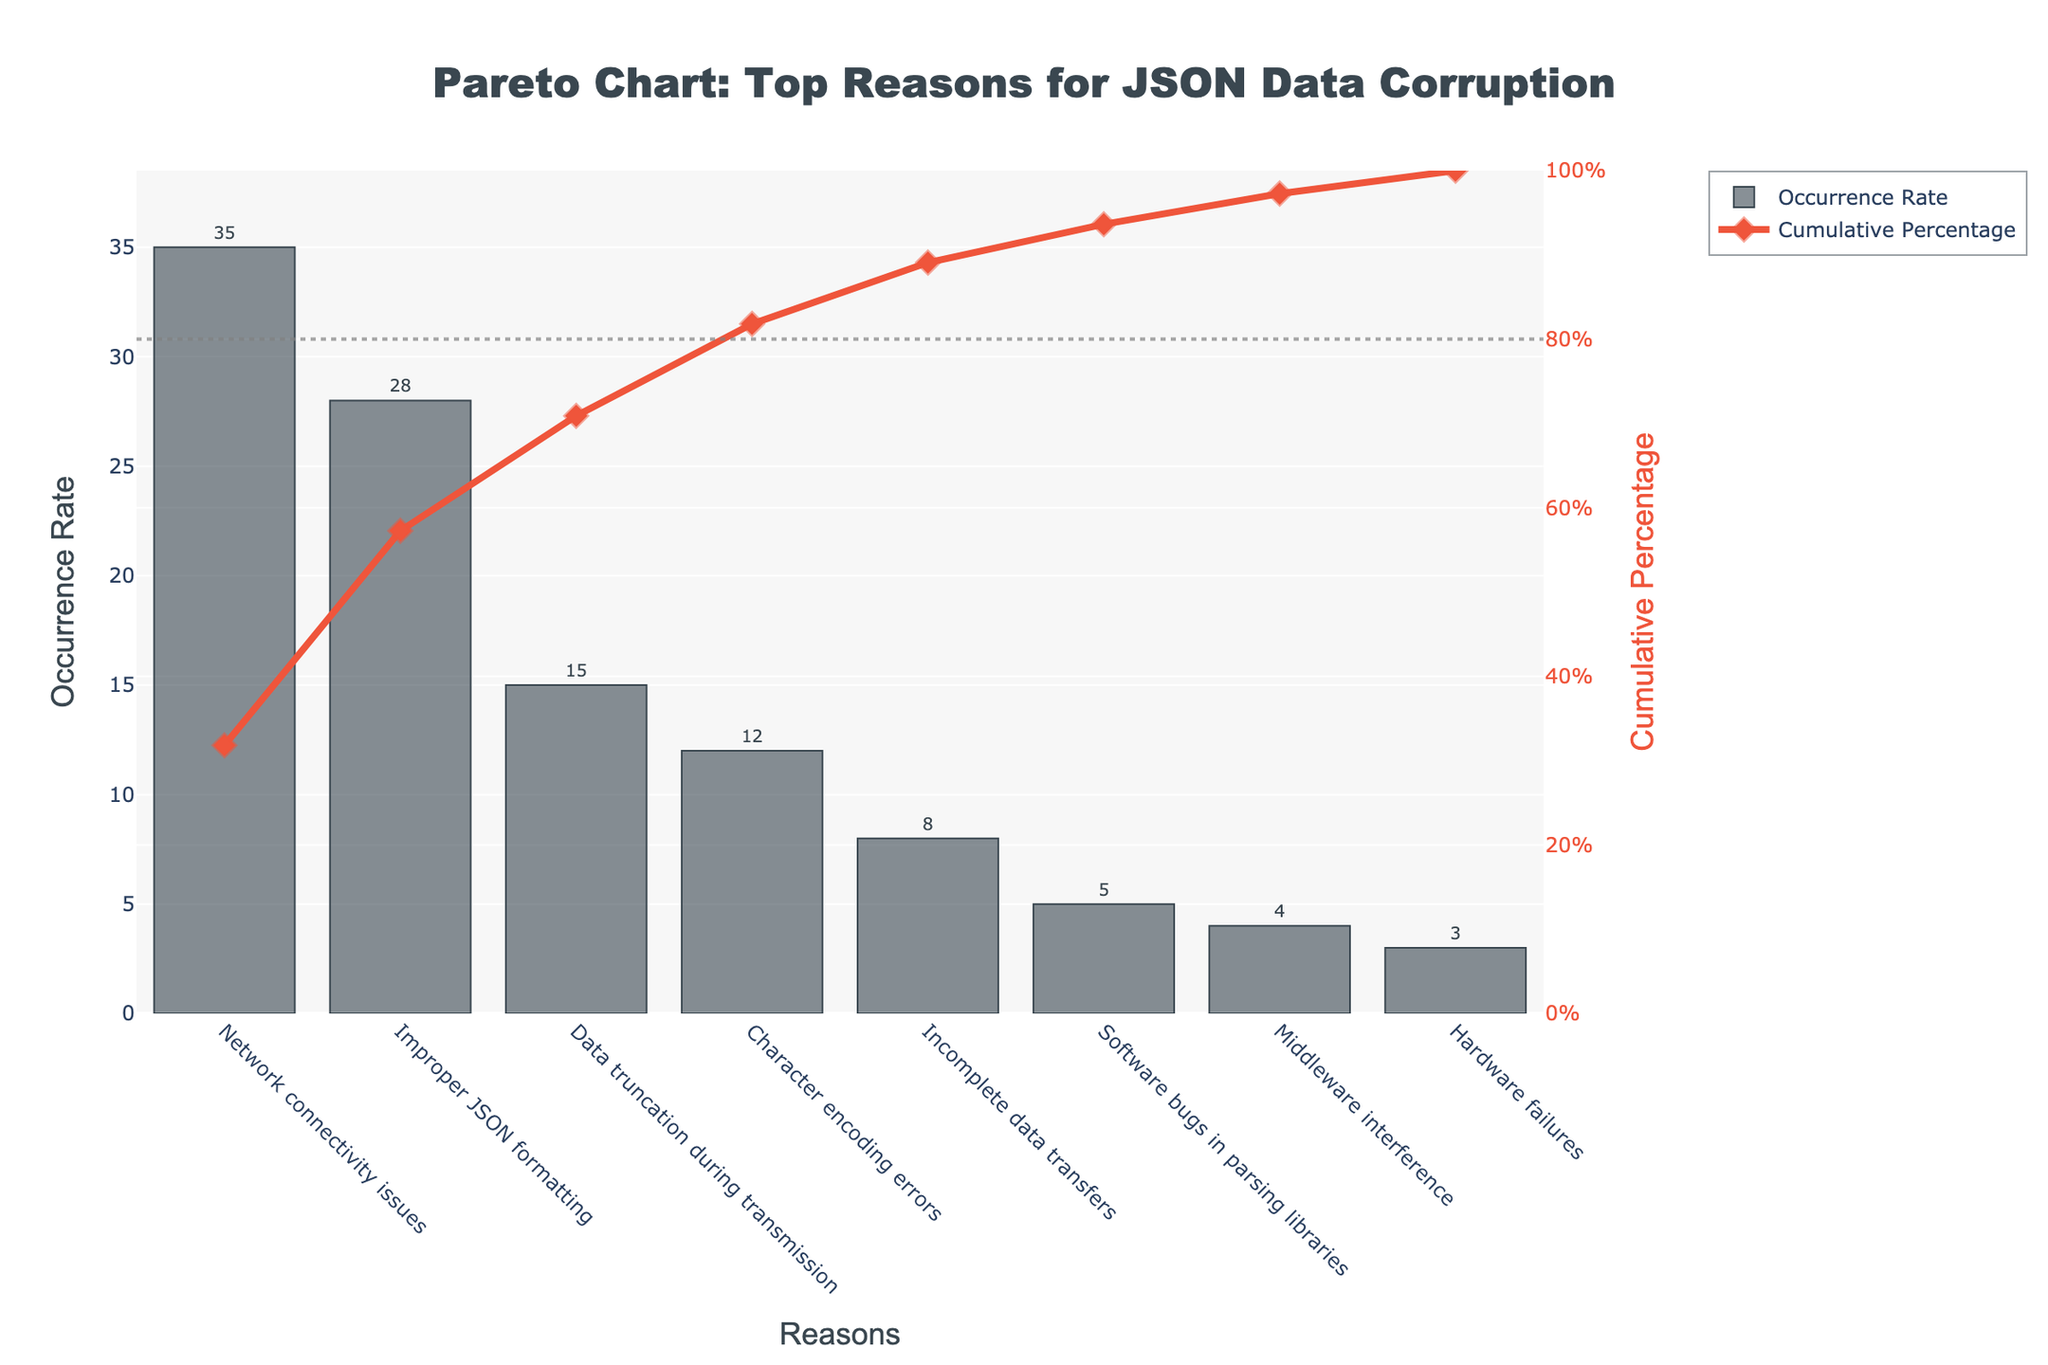What is the most common reason for JSON data corruption? The most common reason can be identified by the highest bar in the chart. In this case, the highest bar corresponds to "Network connectivity issues" with an occurrence rate of 35%.
Answer: Network connectivity issues Which reasons account for more than 50% of JSON data corruption cases when combined? To determine this, look at the cumulative percentage line. Adding up the occurrence rates sequentially from the top until the cumulative percentage exceeds 50%: "Network connectivity issues" (35%) + "Improper JSON formatting" (28%) = 63%.
Answer: Network connectivity issues and Improper JSON formatting By how much does the occurrence rate of "Data truncation during transmission" exceed "Character encoding errors"? Find the occurrence rates for both reasons. "Data truncation during transmission" has an occurrence rate of 15%, and "Character encoding errors" have an occurrence rate of 12%. The difference is calculated as 15% - 12% = 3%.
Answer: 3% What is the cumulative percentage of the top three reasons for JSON data corruption? Add the cumulative percentages for the top three reasons: "Network connectivity issues" (35%), "Improper JSON formatting" (28%), and "Data truncation during transmission" (15%). The sum is 35% + 28% + 15% = 78%.
Answer: 78% Which reason has the lowest occurrence rate for JSON data corruption? The reason with the smallest bar is "Hardware failures," which has an occurrence rate of 3%.
Answer: Hardware failures How many reasons are needed to reach at least 80% cumulative percentage? Check the cumulative percentage line. Summing the occurrence rates from the highest down: "Network connectivity issues" (35%) + "Improper JSON formatting" (28%) + "Data truncation during transmission" (15%) + "Character encoding errors" (12%) = 90%. So, 4 reasons are required.
Answer: Four reasons What is the occurrence rate difference between the most and least common reasons for JSON data corruption? Subtract the occurrence rate of the least common reason (3% for "Hardware failures") from the most common reason (35% for "Network connectivity issues"). The difference is 35% - 3% = 32%.
Answer: 32% What percentage of JSON data corruption is explained by the top two reasons combined? Add the occurrence rates of the top two reasons: "Network connectivity issues" (35%) + "Improper JSON formatting" (28%). The sum is 35% + 28% = 63%.
Answer: 63% Which reason accounts for just under 10% of the data corruption cases? Identify the reason with an occurrence rate close to but less than 10%. "Incomplete data transfers" have an occurrence rate of 8%, which fits this criterion.
Answer: Incomplete data transfers 